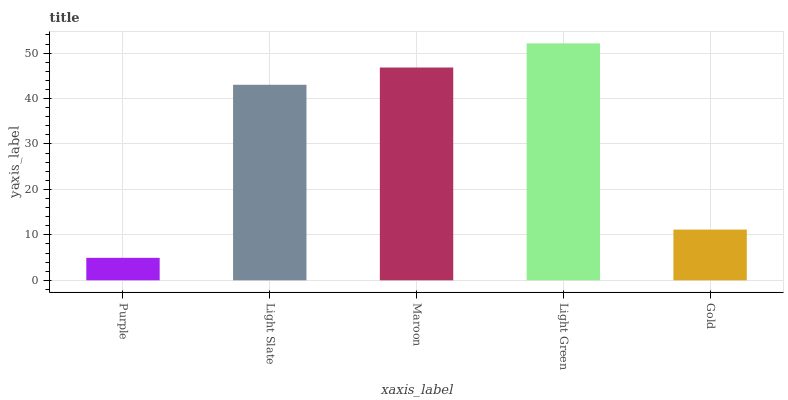Is Purple the minimum?
Answer yes or no. Yes. Is Light Green the maximum?
Answer yes or no. Yes. Is Light Slate the minimum?
Answer yes or no. No. Is Light Slate the maximum?
Answer yes or no. No. Is Light Slate greater than Purple?
Answer yes or no. Yes. Is Purple less than Light Slate?
Answer yes or no. Yes. Is Purple greater than Light Slate?
Answer yes or no. No. Is Light Slate less than Purple?
Answer yes or no. No. Is Light Slate the high median?
Answer yes or no. Yes. Is Light Slate the low median?
Answer yes or no. Yes. Is Purple the high median?
Answer yes or no. No. Is Maroon the low median?
Answer yes or no. No. 